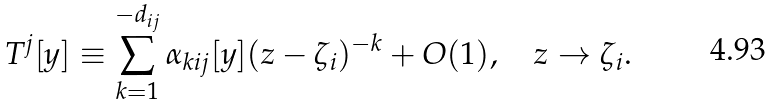<formula> <loc_0><loc_0><loc_500><loc_500>T ^ { j } [ y ] \equiv \sum _ { k = 1 } ^ { - d _ { i j } } \alpha _ { k i j } [ y ] ( z - \zeta _ { i } ) ^ { - k } + O ( 1 ) , \quad z \to \zeta _ { i } .</formula> 